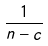Convert formula to latex. <formula><loc_0><loc_0><loc_500><loc_500>\frac { 1 } { n - c }</formula> 